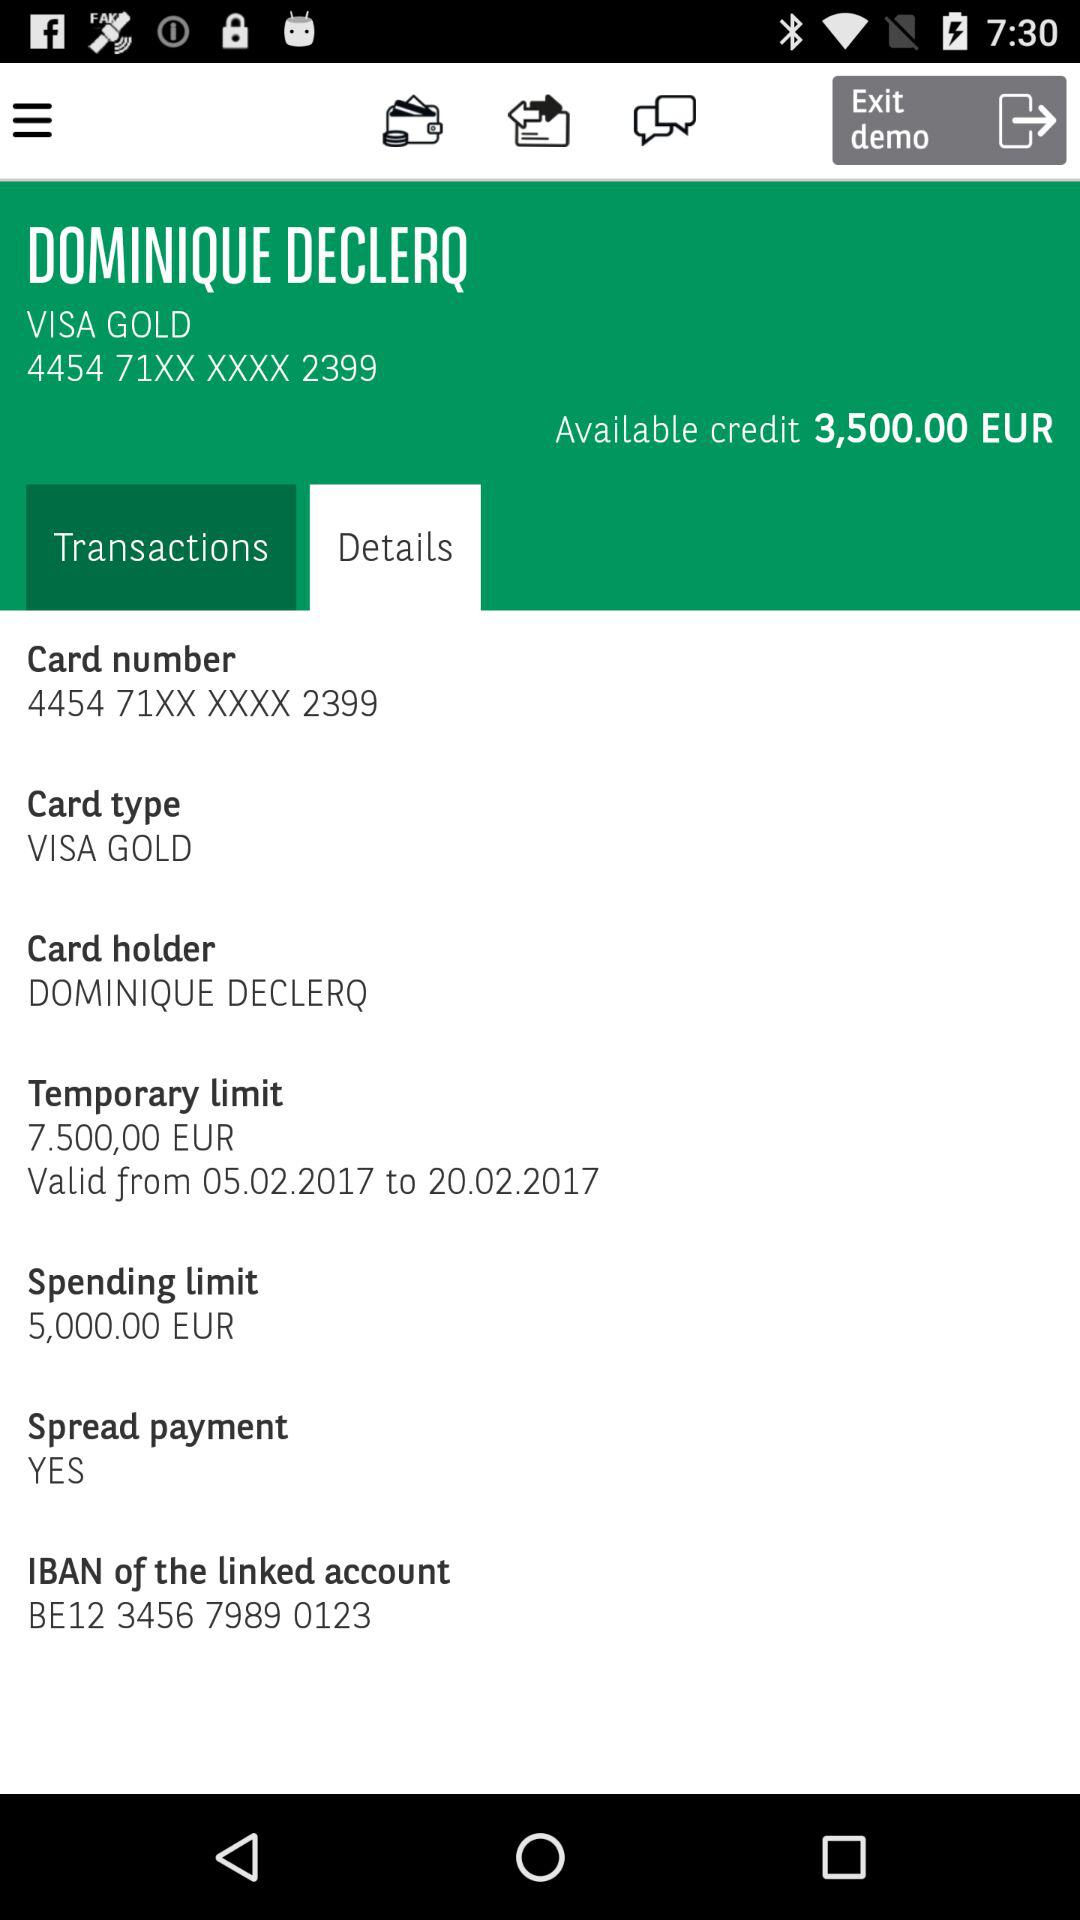What is the card number? The card number is 4454 71XX XXXX 2399. 